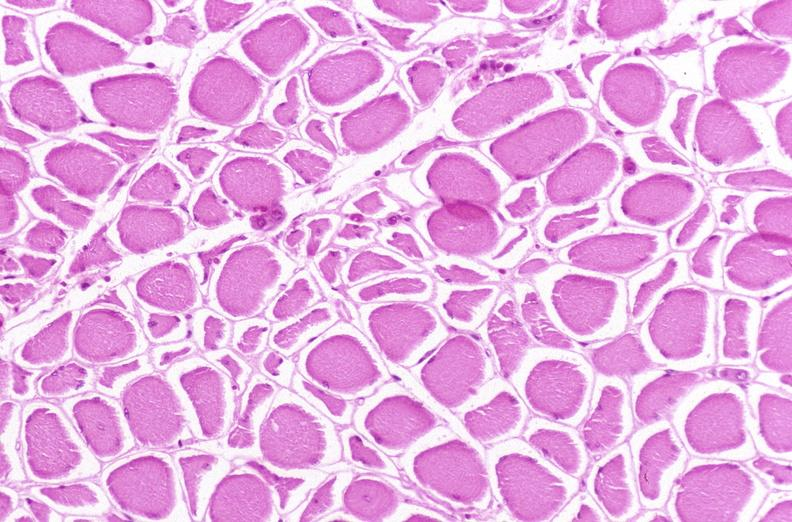s musculoskeletal present?
Answer the question using a single word or phrase. Yes 